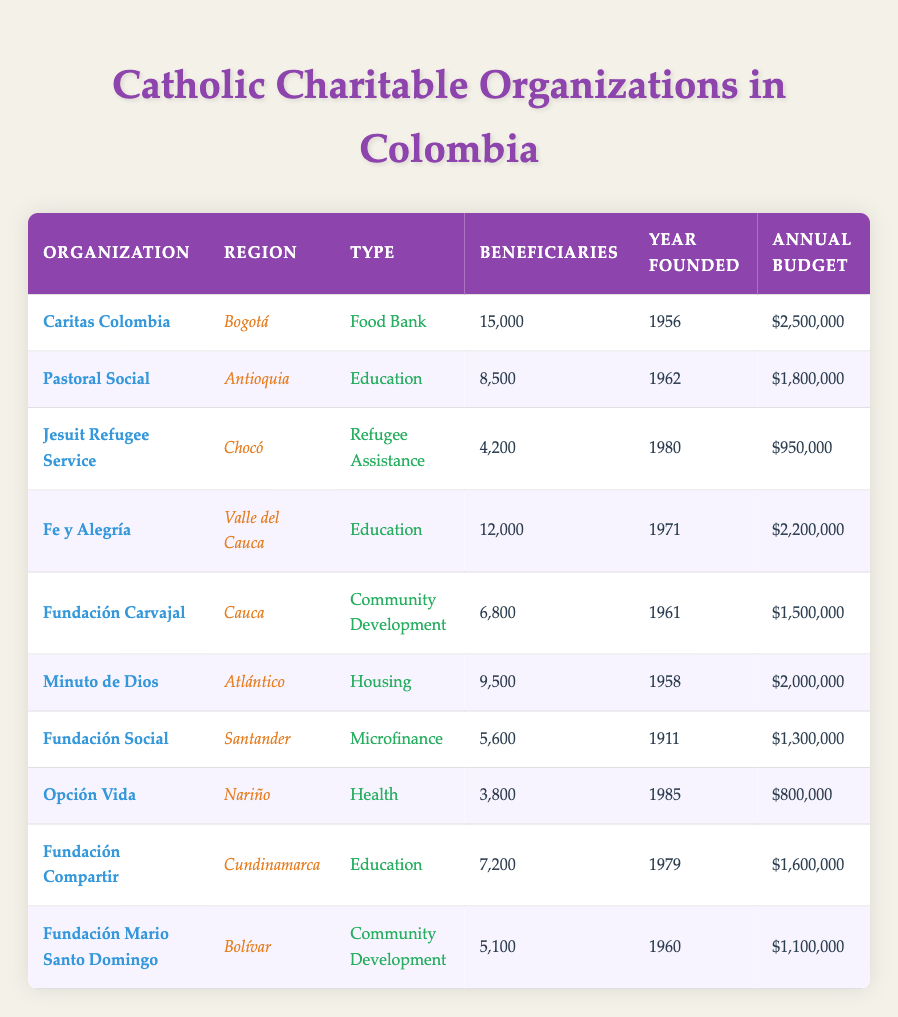What is the total number of beneficiaries across all organizations? To find the total number of beneficiaries, we need to sum the beneficiaries from each organization. The numbers are: 15000 + 8500 + 4200 + 12000 + 6800 + 9500 + 5600 + 3800 + 7200 + 5100. Calculating that gives us 15000 + 8500 = 23500, 23500 + 4200 = 27700, 27700 + 12000 = 39700, 39700 + 6800 = 46500, 46500 + 9500 = 56000, 56000 + 5600 = 61600, 61600 + 3800 = 65400, 65400 + 7200 = 72600, 72600 + 5100 = 77700. Thus, the total is 77700.
Answer: 77700 Which organization has the highest annual budget? To find the organization with the highest annual budget, we examine the "Annual Budget" column: 2500000, 1800000, 950000, 2200000, 1500000, 2000000, 1300000, 800000, 1600000, 1100000. The maximum value is 2500000 from Caritas Colombia.
Answer: Caritas Colombia Is there an organization that helps with health services? We can look through the "Type" column for any health-related services. The only organization listed as providing health services is Opción Vida. Therefore, the answer is yes.
Answer: Yes What is the average annual budget for organizations focused on education? The organizations focused on education are Pastoral Social, Fe y Alegría, and Fundación Compartir with budgets of 1800000, 2200000, and 1600000 respectively. To find the average: First, sum the budgets: 1800000 + 2200000 + 1600000 = 5600000. Then divide by the number of organizations which is 3: 5600000 / 3 = 1866666.67. Thus, the average annual budget for education organizations is approximately 1866667.
Answer: 1866667 Which region has the least number of beneficiaries from Catholic charitable organizations? We need to compare the total beneficiaries for each region: Bogotá (15000), Antioquia (8500), Chocó (4200), Valle del Cauca (12000), Cauca (6800), Atlántico (9500), Santander (5600), Nariño (3800), Cundinamarca (7200), Bolívar (5100). The least number is from Nariño with 3800 beneficiaries.
Answer: Nariño How many years had the oldest organization been active by 2023? The oldest organization is Fundación Social, founded in 1911. To calculate the number of years active by 2023, we subtract the founding year from the current year: 2023 - 1911 = 112 years.
Answer: 112 Are there any organizations established after 1980? Checking the "Year Founded" column, we see that Jesuit Refugee Service (1980), Opción Vida (1985) are established after 1980. Therefore, the answer is yes.
Answer: Yes What is the total annual budget for organizations in the Bolívar and Chocó regions? The organization paying for Bolívar is Fundación Mario Santo Domingo with a budget of 1100000, and for Chocó, it's Jesuit Refugee Service with a budget of 950000. When we sum these: 1100000 + 950000 = 2050000. Hence, the total budget for these regions is 2050000.
Answer: 2050000 